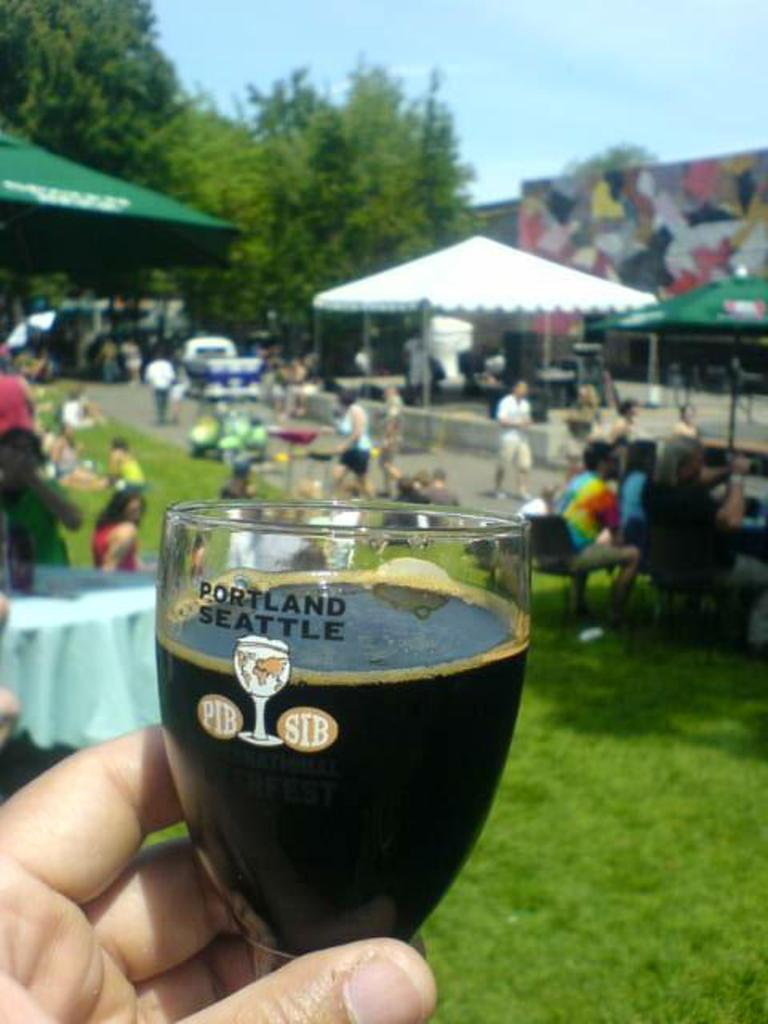<image>
Relay a brief, clear account of the picture shown. a glass full of dark liquid says portland on it 